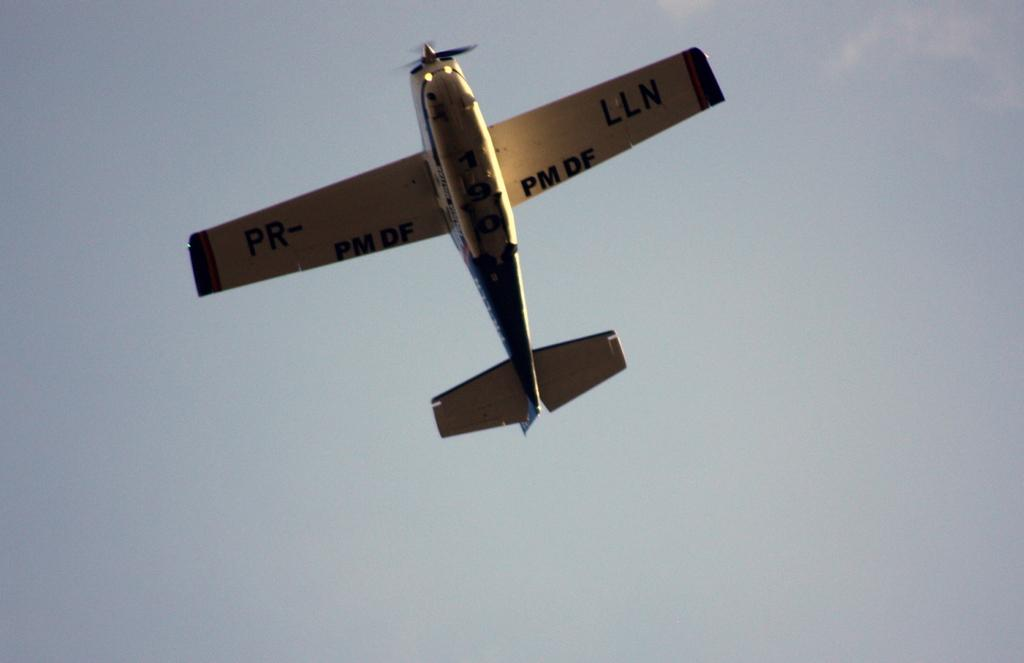What is the main subject of the image? The main subject of the image is an aeroplane. What is the aeroplane doing in the image? The aeroplane is flying in the air. What is the color of the aeroplane? The aeroplane is white in color. What else can be seen in the image besides the aeroplane? The sky is visible in the image. What type of meat can be seen hanging from the aeroplane in the image? There is no meat present in the image, and the aeroplane is not depicted as having any meat hanging from it. 